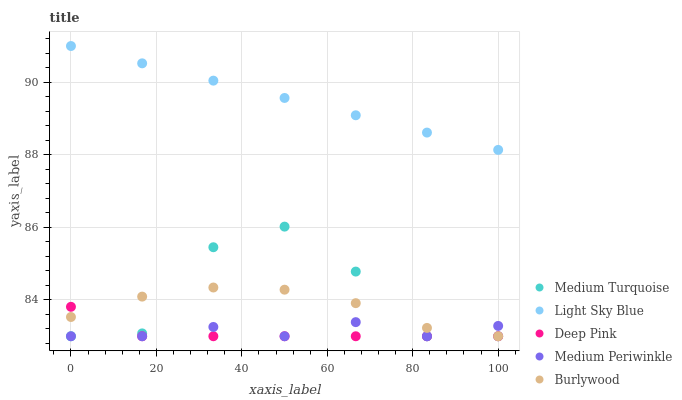Does Deep Pink have the minimum area under the curve?
Answer yes or no. Yes. Does Light Sky Blue have the maximum area under the curve?
Answer yes or no. Yes. Does Medium Periwinkle have the minimum area under the curve?
Answer yes or no. No. Does Medium Periwinkle have the maximum area under the curve?
Answer yes or no. No. Is Light Sky Blue the smoothest?
Answer yes or no. Yes. Is Medium Turquoise the roughest?
Answer yes or no. Yes. Is Medium Periwinkle the smoothest?
Answer yes or no. No. Is Medium Periwinkle the roughest?
Answer yes or no. No. Does Burlywood have the lowest value?
Answer yes or no. Yes. Does Light Sky Blue have the lowest value?
Answer yes or no. No. Does Light Sky Blue have the highest value?
Answer yes or no. Yes. Does Medium Periwinkle have the highest value?
Answer yes or no. No. Is Medium Periwinkle less than Light Sky Blue?
Answer yes or no. Yes. Is Light Sky Blue greater than Medium Periwinkle?
Answer yes or no. Yes. Does Deep Pink intersect Burlywood?
Answer yes or no. Yes. Is Deep Pink less than Burlywood?
Answer yes or no. No. Is Deep Pink greater than Burlywood?
Answer yes or no. No. Does Medium Periwinkle intersect Light Sky Blue?
Answer yes or no. No. 